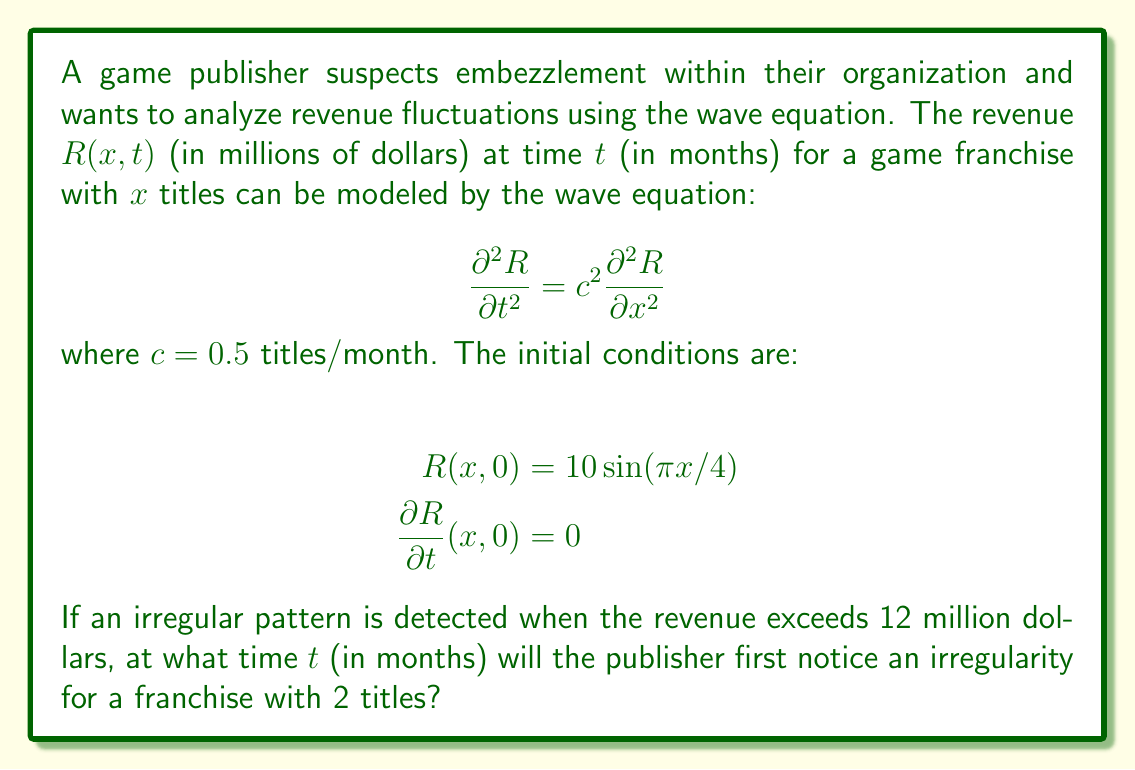Solve this math problem. To solve this problem, we need to use the general solution of the wave equation, which is given by d'Alembert's formula:

$$R(x,t) = f(x-ct) + g(x+ct)$$

where $f$ and $g$ are determined by the initial conditions.

Given the initial conditions:
1. $R(x,0) = 10 \sin(\pi x/4)$
2. $\frac{\partial R}{\partial t}(x,0) = 0$

We can determine that:

$$f(x) = g(x) = 5 \sin(\pi x/4)$$

Therefore, the solution is:

$$R(x,t) = 5 \sin(\pi (x-ct)/4) + 5 \sin(\pi (x+ct)/4)$$

Using the trigonometric identity for the sum of sines, we get:

$$R(x,t) = 10 \sin(\pi x/4) \cos(\pi ct/4)$$

For a franchise with 2 titles, $x = 2$. We need to find when $R(2,t)$ first exceeds 12 million dollars:

$$R(2,t) = 10 \sin(\pi/2) \cos(\pi ct/4)$$
$$R(2,t) = 10 \cos(\pi ct/4)$$

We want to solve:

$$10 \cos(\pi ct/4) > 12$$
$$\cos(\pi ct/4) > 1.2$$

This is impossible for real values of $t$, as the cosine function is bounded between -1 and 1.

However, the closest the revenue gets to 12 million is when $\cos(\pi ct/4) = 1$, which occurs when:

$$\pi ct/4 = 2\pi n, \quad n = 0, 1, 2, ...$$

The smallest positive time this occurs is when $n = 1$:

$$\pi ct/4 = 2\pi$$
$$t = 8/c = 8/(0.5) = 16$$

Therefore, the publisher will never detect an irregularity based on the given criterion, but the revenue will come closest to the threshold at $t = 16$ months.
Answer: The publisher will never detect an irregularity based on the given criterion. The revenue comes closest to the threshold at $t = 16$ months. 